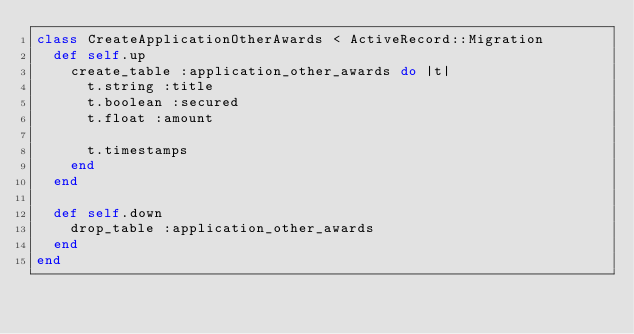<code> <loc_0><loc_0><loc_500><loc_500><_Ruby_>class CreateApplicationOtherAwards < ActiveRecord::Migration
  def self.up
    create_table :application_other_awards do |t|
      t.string :title
      t.boolean :secured
      t.float :amount

      t.timestamps
    end
  end

  def self.down
    drop_table :application_other_awards
  end
end
</code> 